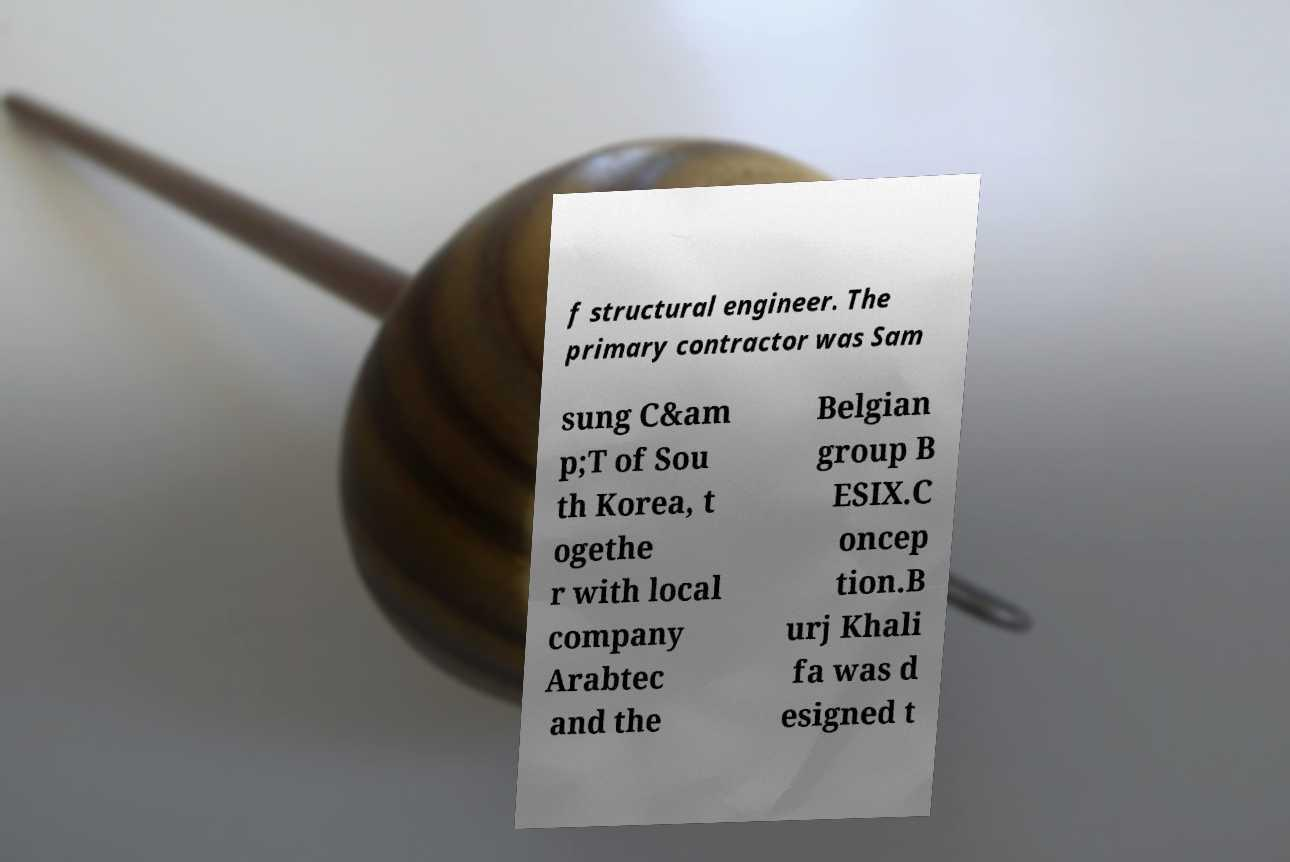I need the written content from this picture converted into text. Can you do that? f structural engineer. The primary contractor was Sam sung C&am p;T of Sou th Korea, t ogethe r with local company Arabtec and the Belgian group B ESIX.C oncep tion.B urj Khali fa was d esigned t 